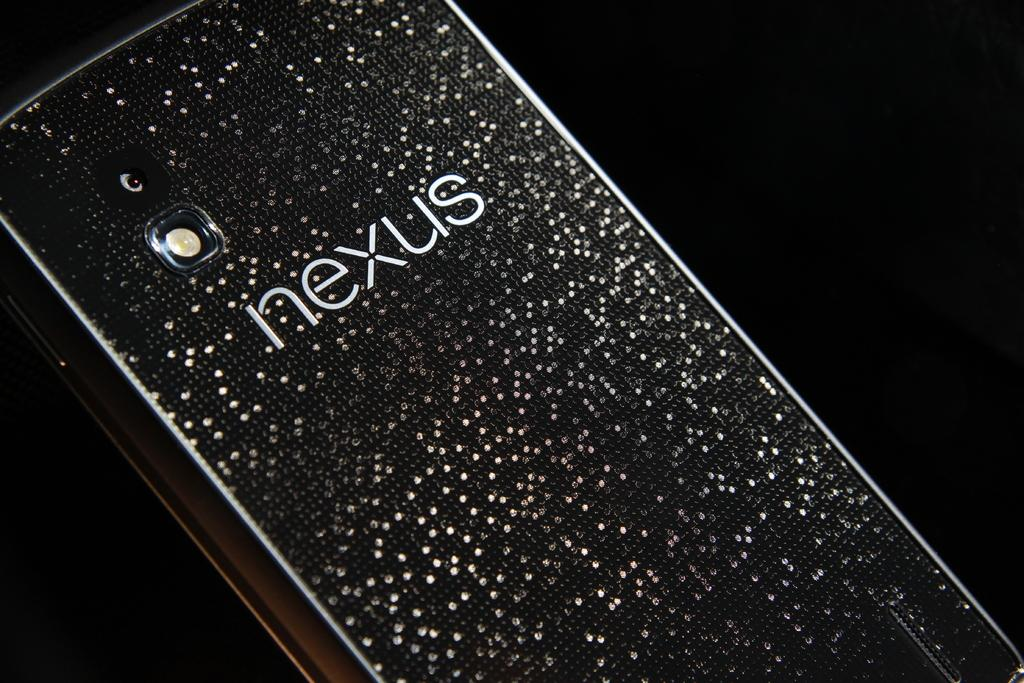Provide a one-sentence caption for the provided image. the word Nexus that is on a phone. 